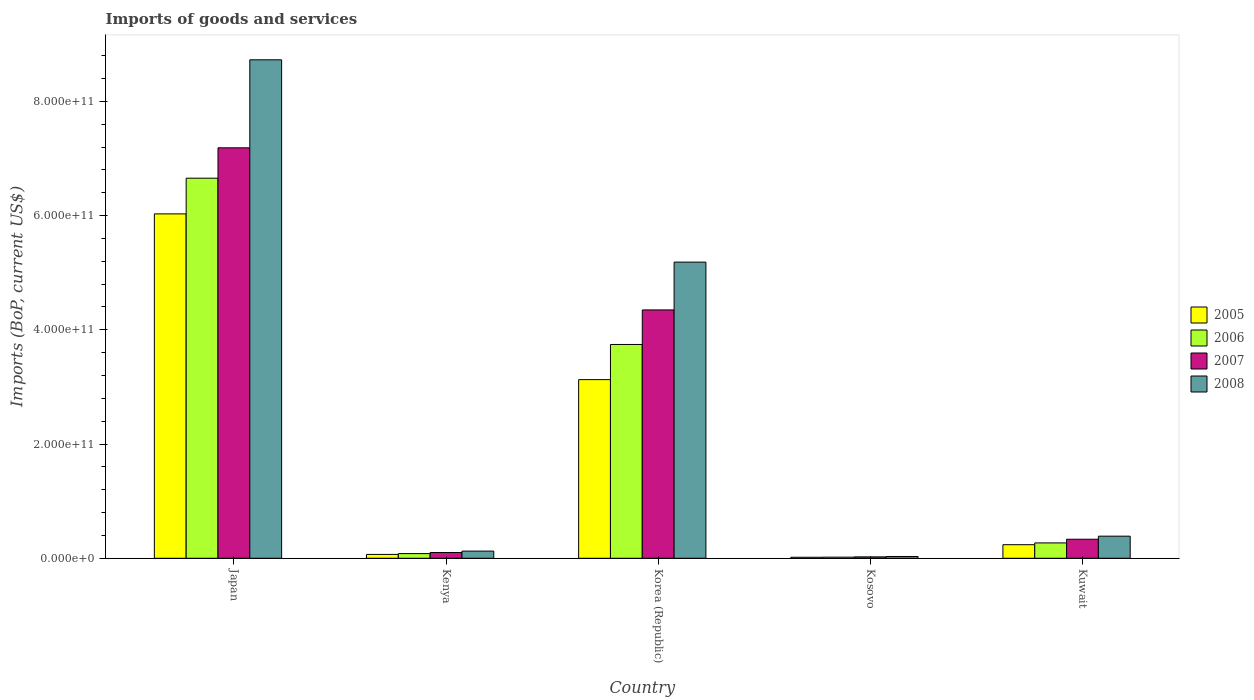Are the number of bars per tick equal to the number of legend labels?
Provide a short and direct response. Yes. Are the number of bars on each tick of the X-axis equal?
Make the answer very short. Yes. How many bars are there on the 5th tick from the right?
Ensure brevity in your answer.  4. What is the amount spent on imports in 2007 in Japan?
Offer a very short reply. 7.19e+11. Across all countries, what is the maximum amount spent on imports in 2006?
Offer a very short reply. 6.66e+11. Across all countries, what is the minimum amount spent on imports in 2008?
Your response must be concise. 3.12e+09. In which country was the amount spent on imports in 2008 maximum?
Provide a short and direct response. Japan. In which country was the amount spent on imports in 2005 minimum?
Provide a succinct answer. Kosovo. What is the total amount spent on imports in 2008 in the graph?
Provide a succinct answer. 1.45e+12. What is the difference between the amount spent on imports in 2006 in Korea (Republic) and that in Kuwait?
Your answer should be very brief. 3.47e+11. What is the difference between the amount spent on imports in 2005 in Korea (Republic) and the amount spent on imports in 2008 in Kenya?
Ensure brevity in your answer.  3.00e+11. What is the average amount spent on imports in 2006 per country?
Keep it short and to the point. 2.15e+11. What is the difference between the amount spent on imports of/in 2007 and amount spent on imports of/in 2005 in Korea (Republic)?
Ensure brevity in your answer.  1.22e+11. In how many countries, is the amount spent on imports in 2005 greater than 560000000000 US$?
Offer a terse response. 1. What is the ratio of the amount spent on imports in 2006 in Kenya to that in Kuwait?
Offer a very short reply. 0.3. Is the amount spent on imports in 2008 in Japan less than that in Kuwait?
Keep it short and to the point. No. Is the difference between the amount spent on imports in 2007 in Japan and Kosovo greater than the difference between the amount spent on imports in 2005 in Japan and Kosovo?
Provide a short and direct response. Yes. What is the difference between the highest and the second highest amount spent on imports in 2008?
Ensure brevity in your answer.  3.54e+11. What is the difference between the highest and the lowest amount spent on imports in 2008?
Ensure brevity in your answer.  8.70e+11. Is it the case that in every country, the sum of the amount spent on imports in 2006 and amount spent on imports in 2007 is greater than the sum of amount spent on imports in 2008 and amount spent on imports in 2005?
Offer a terse response. No. Is it the case that in every country, the sum of the amount spent on imports in 2005 and amount spent on imports in 2006 is greater than the amount spent on imports in 2007?
Ensure brevity in your answer.  Yes. How many bars are there?
Provide a succinct answer. 20. How many countries are there in the graph?
Offer a terse response. 5. What is the difference between two consecutive major ticks on the Y-axis?
Offer a terse response. 2.00e+11. Are the values on the major ticks of Y-axis written in scientific E-notation?
Provide a short and direct response. Yes. Does the graph contain grids?
Offer a very short reply. No. Where does the legend appear in the graph?
Give a very brief answer. Center right. How are the legend labels stacked?
Offer a very short reply. Vertical. What is the title of the graph?
Offer a very short reply. Imports of goods and services. What is the label or title of the Y-axis?
Your response must be concise. Imports (BoP, current US$). What is the Imports (BoP, current US$) of 2005 in Japan?
Your answer should be compact. 6.03e+11. What is the Imports (BoP, current US$) of 2006 in Japan?
Make the answer very short. 6.66e+11. What is the Imports (BoP, current US$) of 2007 in Japan?
Keep it short and to the point. 7.19e+11. What is the Imports (BoP, current US$) in 2008 in Japan?
Make the answer very short. 8.73e+11. What is the Imports (BoP, current US$) of 2005 in Kenya?
Make the answer very short. 6.74e+09. What is the Imports (BoP, current US$) of 2006 in Kenya?
Ensure brevity in your answer.  8.17e+09. What is the Imports (BoP, current US$) of 2007 in Kenya?
Your answer should be very brief. 1.01e+1. What is the Imports (BoP, current US$) in 2008 in Kenya?
Your answer should be compact. 1.26e+1. What is the Imports (BoP, current US$) of 2005 in Korea (Republic)?
Ensure brevity in your answer.  3.13e+11. What is the Imports (BoP, current US$) in 2006 in Korea (Republic)?
Offer a terse response. 3.74e+11. What is the Imports (BoP, current US$) of 2007 in Korea (Republic)?
Ensure brevity in your answer.  4.35e+11. What is the Imports (BoP, current US$) in 2008 in Korea (Republic)?
Your answer should be very brief. 5.19e+11. What is the Imports (BoP, current US$) in 2005 in Kosovo?
Provide a short and direct response. 1.76e+09. What is the Imports (BoP, current US$) of 2006 in Kosovo?
Your answer should be very brief. 1.95e+09. What is the Imports (BoP, current US$) of 2007 in Kosovo?
Ensure brevity in your answer.  2.46e+09. What is the Imports (BoP, current US$) in 2008 in Kosovo?
Make the answer very short. 3.12e+09. What is the Imports (BoP, current US$) in 2005 in Kuwait?
Your response must be concise. 2.38e+1. What is the Imports (BoP, current US$) in 2006 in Kuwait?
Your answer should be compact. 2.69e+1. What is the Imports (BoP, current US$) of 2007 in Kuwait?
Your answer should be very brief. 3.33e+1. What is the Imports (BoP, current US$) in 2008 in Kuwait?
Offer a terse response. 3.87e+1. Across all countries, what is the maximum Imports (BoP, current US$) in 2005?
Offer a terse response. 6.03e+11. Across all countries, what is the maximum Imports (BoP, current US$) of 2006?
Make the answer very short. 6.66e+11. Across all countries, what is the maximum Imports (BoP, current US$) of 2007?
Offer a very short reply. 7.19e+11. Across all countries, what is the maximum Imports (BoP, current US$) in 2008?
Offer a very short reply. 8.73e+11. Across all countries, what is the minimum Imports (BoP, current US$) of 2005?
Your answer should be very brief. 1.76e+09. Across all countries, what is the minimum Imports (BoP, current US$) of 2006?
Offer a very short reply. 1.95e+09. Across all countries, what is the minimum Imports (BoP, current US$) in 2007?
Provide a short and direct response. 2.46e+09. Across all countries, what is the minimum Imports (BoP, current US$) of 2008?
Offer a very short reply. 3.12e+09. What is the total Imports (BoP, current US$) of 2005 in the graph?
Your answer should be very brief. 9.48e+11. What is the total Imports (BoP, current US$) of 2006 in the graph?
Give a very brief answer. 1.08e+12. What is the total Imports (BoP, current US$) in 2007 in the graph?
Offer a very short reply. 1.20e+12. What is the total Imports (BoP, current US$) of 2008 in the graph?
Provide a short and direct response. 1.45e+12. What is the difference between the Imports (BoP, current US$) of 2005 in Japan and that in Kenya?
Ensure brevity in your answer.  5.96e+11. What is the difference between the Imports (BoP, current US$) of 2006 in Japan and that in Kenya?
Ensure brevity in your answer.  6.57e+11. What is the difference between the Imports (BoP, current US$) in 2007 in Japan and that in Kenya?
Keep it short and to the point. 7.09e+11. What is the difference between the Imports (BoP, current US$) of 2008 in Japan and that in Kenya?
Give a very brief answer. 8.60e+11. What is the difference between the Imports (BoP, current US$) in 2005 in Japan and that in Korea (Republic)?
Give a very brief answer. 2.90e+11. What is the difference between the Imports (BoP, current US$) in 2006 in Japan and that in Korea (Republic)?
Offer a very short reply. 2.91e+11. What is the difference between the Imports (BoP, current US$) of 2007 in Japan and that in Korea (Republic)?
Your answer should be compact. 2.84e+11. What is the difference between the Imports (BoP, current US$) of 2008 in Japan and that in Korea (Republic)?
Your answer should be compact. 3.54e+11. What is the difference between the Imports (BoP, current US$) of 2005 in Japan and that in Kosovo?
Make the answer very short. 6.01e+11. What is the difference between the Imports (BoP, current US$) of 2006 in Japan and that in Kosovo?
Make the answer very short. 6.64e+11. What is the difference between the Imports (BoP, current US$) in 2007 in Japan and that in Kosovo?
Your answer should be very brief. 7.16e+11. What is the difference between the Imports (BoP, current US$) in 2008 in Japan and that in Kosovo?
Give a very brief answer. 8.70e+11. What is the difference between the Imports (BoP, current US$) of 2005 in Japan and that in Kuwait?
Give a very brief answer. 5.79e+11. What is the difference between the Imports (BoP, current US$) in 2006 in Japan and that in Kuwait?
Your response must be concise. 6.39e+11. What is the difference between the Imports (BoP, current US$) in 2007 in Japan and that in Kuwait?
Make the answer very short. 6.85e+11. What is the difference between the Imports (BoP, current US$) of 2008 in Japan and that in Kuwait?
Your response must be concise. 8.34e+11. What is the difference between the Imports (BoP, current US$) of 2005 in Kenya and that in Korea (Republic)?
Offer a terse response. -3.06e+11. What is the difference between the Imports (BoP, current US$) in 2006 in Kenya and that in Korea (Republic)?
Offer a very short reply. -3.66e+11. What is the difference between the Imports (BoP, current US$) of 2007 in Kenya and that in Korea (Republic)?
Ensure brevity in your answer.  -4.25e+11. What is the difference between the Imports (BoP, current US$) of 2008 in Kenya and that in Korea (Republic)?
Offer a very short reply. -5.06e+11. What is the difference between the Imports (BoP, current US$) of 2005 in Kenya and that in Kosovo?
Your response must be concise. 4.97e+09. What is the difference between the Imports (BoP, current US$) in 2006 in Kenya and that in Kosovo?
Your answer should be compact. 6.22e+09. What is the difference between the Imports (BoP, current US$) in 2007 in Kenya and that in Kosovo?
Keep it short and to the point. 7.60e+09. What is the difference between the Imports (BoP, current US$) of 2008 in Kenya and that in Kosovo?
Your answer should be very brief. 9.44e+09. What is the difference between the Imports (BoP, current US$) of 2005 in Kenya and that in Kuwait?
Ensure brevity in your answer.  -1.70e+1. What is the difference between the Imports (BoP, current US$) in 2006 in Kenya and that in Kuwait?
Offer a terse response. -1.87e+1. What is the difference between the Imports (BoP, current US$) of 2007 in Kenya and that in Kuwait?
Your response must be concise. -2.32e+1. What is the difference between the Imports (BoP, current US$) of 2008 in Kenya and that in Kuwait?
Your answer should be very brief. -2.62e+1. What is the difference between the Imports (BoP, current US$) of 2005 in Korea (Republic) and that in Kosovo?
Provide a succinct answer. 3.11e+11. What is the difference between the Imports (BoP, current US$) in 2006 in Korea (Republic) and that in Kosovo?
Ensure brevity in your answer.  3.72e+11. What is the difference between the Imports (BoP, current US$) of 2007 in Korea (Republic) and that in Kosovo?
Give a very brief answer. 4.32e+11. What is the difference between the Imports (BoP, current US$) in 2008 in Korea (Republic) and that in Kosovo?
Provide a short and direct response. 5.15e+11. What is the difference between the Imports (BoP, current US$) in 2005 in Korea (Republic) and that in Kuwait?
Provide a succinct answer. 2.89e+11. What is the difference between the Imports (BoP, current US$) in 2006 in Korea (Republic) and that in Kuwait?
Make the answer very short. 3.47e+11. What is the difference between the Imports (BoP, current US$) in 2007 in Korea (Republic) and that in Kuwait?
Ensure brevity in your answer.  4.02e+11. What is the difference between the Imports (BoP, current US$) of 2008 in Korea (Republic) and that in Kuwait?
Provide a short and direct response. 4.80e+11. What is the difference between the Imports (BoP, current US$) of 2005 in Kosovo and that in Kuwait?
Your answer should be very brief. -2.20e+1. What is the difference between the Imports (BoP, current US$) in 2006 in Kosovo and that in Kuwait?
Your answer should be compact. -2.49e+1. What is the difference between the Imports (BoP, current US$) of 2007 in Kosovo and that in Kuwait?
Offer a very short reply. -3.08e+1. What is the difference between the Imports (BoP, current US$) of 2008 in Kosovo and that in Kuwait?
Provide a short and direct response. -3.56e+1. What is the difference between the Imports (BoP, current US$) of 2005 in Japan and the Imports (BoP, current US$) of 2006 in Kenya?
Provide a succinct answer. 5.95e+11. What is the difference between the Imports (BoP, current US$) in 2005 in Japan and the Imports (BoP, current US$) in 2007 in Kenya?
Offer a very short reply. 5.93e+11. What is the difference between the Imports (BoP, current US$) of 2005 in Japan and the Imports (BoP, current US$) of 2008 in Kenya?
Make the answer very short. 5.90e+11. What is the difference between the Imports (BoP, current US$) in 2006 in Japan and the Imports (BoP, current US$) in 2007 in Kenya?
Offer a terse response. 6.55e+11. What is the difference between the Imports (BoP, current US$) in 2006 in Japan and the Imports (BoP, current US$) in 2008 in Kenya?
Provide a succinct answer. 6.53e+11. What is the difference between the Imports (BoP, current US$) in 2007 in Japan and the Imports (BoP, current US$) in 2008 in Kenya?
Provide a succinct answer. 7.06e+11. What is the difference between the Imports (BoP, current US$) of 2005 in Japan and the Imports (BoP, current US$) of 2006 in Korea (Republic)?
Your answer should be compact. 2.29e+11. What is the difference between the Imports (BoP, current US$) of 2005 in Japan and the Imports (BoP, current US$) of 2007 in Korea (Republic)?
Your response must be concise. 1.68e+11. What is the difference between the Imports (BoP, current US$) of 2005 in Japan and the Imports (BoP, current US$) of 2008 in Korea (Republic)?
Your response must be concise. 8.45e+1. What is the difference between the Imports (BoP, current US$) in 2006 in Japan and the Imports (BoP, current US$) in 2007 in Korea (Republic)?
Make the answer very short. 2.31e+11. What is the difference between the Imports (BoP, current US$) in 2006 in Japan and the Imports (BoP, current US$) in 2008 in Korea (Republic)?
Make the answer very short. 1.47e+11. What is the difference between the Imports (BoP, current US$) in 2007 in Japan and the Imports (BoP, current US$) in 2008 in Korea (Republic)?
Your answer should be compact. 2.00e+11. What is the difference between the Imports (BoP, current US$) of 2005 in Japan and the Imports (BoP, current US$) of 2006 in Kosovo?
Your answer should be very brief. 6.01e+11. What is the difference between the Imports (BoP, current US$) of 2005 in Japan and the Imports (BoP, current US$) of 2007 in Kosovo?
Your response must be concise. 6.01e+11. What is the difference between the Imports (BoP, current US$) of 2005 in Japan and the Imports (BoP, current US$) of 2008 in Kosovo?
Ensure brevity in your answer.  6.00e+11. What is the difference between the Imports (BoP, current US$) of 2006 in Japan and the Imports (BoP, current US$) of 2007 in Kosovo?
Provide a succinct answer. 6.63e+11. What is the difference between the Imports (BoP, current US$) in 2006 in Japan and the Imports (BoP, current US$) in 2008 in Kosovo?
Give a very brief answer. 6.62e+11. What is the difference between the Imports (BoP, current US$) of 2007 in Japan and the Imports (BoP, current US$) of 2008 in Kosovo?
Offer a terse response. 7.16e+11. What is the difference between the Imports (BoP, current US$) in 2005 in Japan and the Imports (BoP, current US$) in 2006 in Kuwait?
Keep it short and to the point. 5.76e+11. What is the difference between the Imports (BoP, current US$) in 2005 in Japan and the Imports (BoP, current US$) in 2007 in Kuwait?
Ensure brevity in your answer.  5.70e+11. What is the difference between the Imports (BoP, current US$) of 2005 in Japan and the Imports (BoP, current US$) of 2008 in Kuwait?
Your answer should be very brief. 5.64e+11. What is the difference between the Imports (BoP, current US$) of 2006 in Japan and the Imports (BoP, current US$) of 2007 in Kuwait?
Make the answer very short. 6.32e+11. What is the difference between the Imports (BoP, current US$) in 2006 in Japan and the Imports (BoP, current US$) in 2008 in Kuwait?
Your answer should be compact. 6.27e+11. What is the difference between the Imports (BoP, current US$) of 2007 in Japan and the Imports (BoP, current US$) of 2008 in Kuwait?
Provide a succinct answer. 6.80e+11. What is the difference between the Imports (BoP, current US$) in 2005 in Kenya and the Imports (BoP, current US$) in 2006 in Korea (Republic)?
Provide a succinct answer. -3.68e+11. What is the difference between the Imports (BoP, current US$) of 2005 in Kenya and the Imports (BoP, current US$) of 2007 in Korea (Republic)?
Make the answer very short. -4.28e+11. What is the difference between the Imports (BoP, current US$) of 2005 in Kenya and the Imports (BoP, current US$) of 2008 in Korea (Republic)?
Give a very brief answer. -5.12e+11. What is the difference between the Imports (BoP, current US$) of 2006 in Kenya and the Imports (BoP, current US$) of 2007 in Korea (Republic)?
Offer a very short reply. -4.27e+11. What is the difference between the Imports (BoP, current US$) of 2006 in Kenya and the Imports (BoP, current US$) of 2008 in Korea (Republic)?
Your response must be concise. -5.10e+11. What is the difference between the Imports (BoP, current US$) in 2007 in Kenya and the Imports (BoP, current US$) in 2008 in Korea (Republic)?
Your response must be concise. -5.09e+11. What is the difference between the Imports (BoP, current US$) of 2005 in Kenya and the Imports (BoP, current US$) of 2006 in Kosovo?
Offer a terse response. 4.79e+09. What is the difference between the Imports (BoP, current US$) in 2005 in Kenya and the Imports (BoP, current US$) in 2007 in Kosovo?
Your answer should be very brief. 4.28e+09. What is the difference between the Imports (BoP, current US$) in 2005 in Kenya and the Imports (BoP, current US$) in 2008 in Kosovo?
Provide a short and direct response. 3.62e+09. What is the difference between the Imports (BoP, current US$) of 2006 in Kenya and the Imports (BoP, current US$) of 2007 in Kosovo?
Ensure brevity in your answer.  5.71e+09. What is the difference between the Imports (BoP, current US$) of 2006 in Kenya and the Imports (BoP, current US$) of 2008 in Kosovo?
Keep it short and to the point. 5.05e+09. What is the difference between the Imports (BoP, current US$) of 2007 in Kenya and the Imports (BoP, current US$) of 2008 in Kosovo?
Your response must be concise. 6.94e+09. What is the difference between the Imports (BoP, current US$) in 2005 in Kenya and the Imports (BoP, current US$) in 2006 in Kuwait?
Offer a very short reply. -2.01e+1. What is the difference between the Imports (BoP, current US$) in 2005 in Kenya and the Imports (BoP, current US$) in 2007 in Kuwait?
Keep it short and to the point. -2.66e+1. What is the difference between the Imports (BoP, current US$) in 2005 in Kenya and the Imports (BoP, current US$) in 2008 in Kuwait?
Your answer should be compact. -3.20e+1. What is the difference between the Imports (BoP, current US$) of 2006 in Kenya and the Imports (BoP, current US$) of 2007 in Kuwait?
Offer a very short reply. -2.51e+1. What is the difference between the Imports (BoP, current US$) in 2006 in Kenya and the Imports (BoP, current US$) in 2008 in Kuwait?
Provide a short and direct response. -3.05e+1. What is the difference between the Imports (BoP, current US$) of 2007 in Kenya and the Imports (BoP, current US$) of 2008 in Kuwait?
Offer a very short reply. -2.87e+1. What is the difference between the Imports (BoP, current US$) in 2005 in Korea (Republic) and the Imports (BoP, current US$) in 2006 in Kosovo?
Make the answer very short. 3.11e+11. What is the difference between the Imports (BoP, current US$) of 2005 in Korea (Republic) and the Imports (BoP, current US$) of 2007 in Kosovo?
Your response must be concise. 3.10e+11. What is the difference between the Imports (BoP, current US$) in 2005 in Korea (Republic) and the Imports (BoP, current US$) in 2008 in Kosovo?
Provide a short and direct response. 3.10e+11. What is the difference between the Imports (BoP, current US$) in 2006 in Korea (Republic) and the Imports (BoP, current US$) in 2007 in Kosovo?
Provide a succinct answer. 3.72e+11. What is the difference between the Imports (BoP, current US$) in 2006 in Korea (Republic) and the Imports (BoP, current US$) in 2008 in Kosovo?
Offer a very short reply. 3.71e+11. What is the difference between the Imports (BoP, current US$) of 2007 in Korea (Republic) and the Imports (BoP, current US$) of 2008 in Kosovo?
Provide a succinct answer. 4.32e+11. What is the difference between the Imports (BoP, current US$) of 2005 in Korea (Republic) and the Imports (BoP, current US$) of 2006 in Kuwait?
Ensure brevity in your answer.  2.86e+11. What is the difference between the Imports (BoP, current US$) of 2005 in Korea (Republic) and the Imports (BoP, current US$) of 2007 in Kuwait?
Give a very brief answer. 2.79e+11. What is the difference between the Imports (BoP, current US$) in 2005 in Korea (Republic) and the Imports (BoP, current US$) in 2008 in Kuwait?
Your answer should be very brief. 2.74e+11. What is the difference between the Imports (BoP, current US$) of 2006 in Korea (Republic) and the Imports (BoP, current US$) of 2007 in Kuwait?
Provide a short and direct response. 3.41e+11. What is the difference between the Imports (BoP, current US$) of 2006 in Korea (Republic) and the Imports (BoP, current US$) of 2008 in Kuwait?
Offer a terse response. 3.36e+11. What is the difference between the Imports (BoP, current US$) of 2007 in Korea (Republic) and the Imports (BoP, current US$) of 2008 in Kuwait?
Provide a succinct answer. 3.96e+11. What is the difference between the Imports (BoP, current US$) in 2005 in Kosovo and the Imports (BoP, current US$) in 2006 in Kuwait?
Give a very brief answer. -2.51e+1. What is the difference between the Imports (BoP, current US$) of 2005 in Kosovo and the Imports (BoP, current US$) of 2007 in Kuwait?
Keep it short and to the point. -3.15e+1. What is the difference between the Imports (BoP, current US$) in 2005 in Kosovo and the Imports (BoP, current US$) in 2008 in Kuwait?
Keep it short and to the point. -3.70e+1. What is the difference between the Imports (BoP, current US$) of 2006 in Kosovo and the Imports (BoP, current US$) of 2007 in Kuwait?
Offer a very short reply. -3.14e+1. What is the difference between the Imports (BoP, current US$) in 2006 in Kosovo and the Imports (BoP, current US$) in 2008 in Kuwait?
Offer a very short reply. -3.68e+1. What is the difference between the Imports (BoP, current US$) of 2007 in Kosovo and the Imports (BoP, current US$) of 2008 in Kuwait?
Offer a terse response. -3.63e+1. What is the average Imports (BoP, current US$) in 2005 per country?
Provide a short and direct response. 1.90e+11. What is the average Imports (BoP, current US$) of 2006 per country?
Provide a short and direct response. 2.15e+11. What is the average Imports (BoP, current US$) in 2007 per country?
Provide a succinct answer. 2.40e+11. What is the average Imports (BoP, current US$) in 2008 per country?
Ensure brevity in your answer.  2.89e+11. What is the difference between the Imports (BoP, current US$) in 2005 and Imports (BoP, current US$) in 2006 in Japan?
Provide a short and direct response. -6.25e+1. What is the difference between the Imports (BoP, current US$) in 2005 and Imports (BoP, current US$) in 2007 in Japan?
Your answer should be very brief. -1.16e+11. What is the difference between the Imports (BoP, current US$) of 2005 and Imports (BoP, current US$) of 2008 in Japan?
Offer a very short reply. -2.70e+11. What is the difference between the Imports (BoP, current US$) of 2006 and Imports (BoP, current US$) of 2007 in Japan?
Your answer should be compact. -5.32e+1. What is the difference between the Imports (BoP, current US$) in 2006 and Imports (BoP, current US$) in 2008 in Japan?
Offer a terse response. -2.07e+11. What is the difference between the Imports (BoP, current US$) in 2007 and Imports (BoP, current US$) in 2008 in Japan?
Your answer should be very brief. -1.54e+11. What is the difference between the Imports (BoP, current US$) of 2005 and Imports (BoP, current US$) of 2006 in Kenya?
Keep it short and to the point. -1.43e+09. What is the difference between the Imports (BoP, current US$) of 2005 and Imports (BoP, current US$) of 2007 in Kenya?
Provide a succinct answer. -3.32e+09. What is the difference between the Imports (BoP, current US$) in 2005 and Imports (BoP, current US$) in 2008 in Kenya?
Your answer should be very brief. -5.82e+09. What is the difference between the Imports (BoP, current US$) in 2006 and Imports (BoP, current US$) in 2007 in Kenya?
Your answer should be compact. -1.89e+09. What is the difference between the Imports (BoP, current US$) of 2006 and Imports (BoP, current US$) of 2008 in Kenya?
Offer a very short reply. -4.39e+09. What is the difference between the Imports (BoP, current US$) in 2007 and Imports (BoP, current US$) in 2008 in Kenya?
Provide a succinct answer. -2.50e+09. What is the difference between the Imports (BoP, current US$) in 2005 and Imports (BoP, current US$) in 2006 in Korea (Republic)?
Offer a terse response. -6.16e+1. What is the difference between the Imports (BoP, current US$) in 2005 and Imports (BoP, current US$) in 2007 in Korea (Republic)?
Give a very brief answer. -1.22e+11. What is the difference between the Imports (BoP, current US$) of 2005 and Imports (BoP, current US$) of 2008 in Korea (Republic)?
Make the answer very short. -2.06e+11. What is the difference between the Imports (BoP, current US$) in 2006 and Imports (BoP, current US$) in 2007 in Korea (Republic)?
Make the answer very short. -6.05e+1. What is the difference between the Imports (BoP, current US$) in 2006 and Imports (BoP, current US$) in 2008 in Korea (Republic)?
Your answer should be very brief. -1.44e+11. What is the difference between the Imports (BoP, current US$) of 2007 and Imports (BoP, current US$) of 2008 in Korea (Republic)?
Your answer should be very brief. -8.37e+1. What is the difference between the Imports (BoP, current US$) of 2005 and Imports (BoP, current US$) of 2006 in Kosovo?
Your answer should be very brief. -1.86e+08. What is the difference between the Imports (BoP, current US$) of 2005 and Imports (BoP, current US$) of 2007 in Kosovo?
Provide a succinct answer. -6.96e+08. What is the difference between the Imports (BoP, current US$) of 2005 and Imports (BoP, current US$) of 2008 in Kosovo?
Ensure brevity in your answer.  -1.36e+09. What is the difference between the Imports (BoP, current US$) of 2006 and Imports (BoP, current US$) of 2007 in Kosovo?
Keep it short and to the point. -5.10e+08. What is the difference between the Imports (BoP, current US$) of 2006 and Imports (BoP, current US$) of 2008 in Kosovo?
Give a very brief answer. -1.17e+09. What is the difference between the Imports (BoP, current US$) in 2007 and Imports (BoP, current US$) in 2008 in Kosovo?
Your answer should be very brief. -6.61e+08. What is the difference between the Imports (BoP, current US$) of 2005 and Imports (BoP, current US$) of 2006 in Kuwait?
Offer a very short reply. -3.11e+09. What is the difference between the Imports (BoP, current US$) of 2005 and Imports (BoP, current US$) of 2007 in Kuwait?
Your response must be concise. -9.54e+09. What is the difference between the Imports (BoP, current US$) in 2005 and Imports (BoP, current US$) in 2008 in Kuwait?
Keep it short and to the point. -1.49e+1. What is the difference between the Imports (BoP, current US$) in 2006 and Imports (BoP, current US$) in 2007 in Kuwait?
Offer a terse response. -6.43e+09. What is the difference between the Imports (BoP, current US$) of 2006 and Imports (BoP, current US$) of 2008 in Kuwait?
Your response must be concise. -1.18e+1. What is the difference between the Imports (BoP, current US$) of 2007 and Imports (BoP, current US$) of 2008 in Kuwait?
Keep it short and to the point. -5.41e+09. What is the ratio of the Imports (BoP, current US$) of 2005 in Japan to that in Kenya?
Provide a short and direct response. 89.49. What is the ratio of the Imports (BoP, current US$) in 2006 in Japan to that in Kenya?
Provide a succinct answer. 81.45. What is the ratio of the Imports (BoP, current US$) in 2007 in Japan to that in Kenya?
Make the answer very short. 71.45. What is the ratio of the Imports (BoP, current US$) in 2008 in Japan to that in Kenya?
Offer a very short reply. 69.5. What is the ratio of the Imports (BoP, current US$) in 2005 in Japan to that in Korea (Republic)?
Your answer should be compact. 1.93. What is the ratio of the Imports (BoP, current US$) in 2006 in Japan to that in Korea (Republic)?
Keep it short and to the point. 1.78. What is the ratio of the Imports (BoP, current US$) of 2007 in Japan to that in Korea (Republic)?
Your answer should be compact. 1.65. What is the ratio of the Imports (BoP, current US$) in 2008 in Japan to that in Korea (Republic)?
Keep it short and to the point. 1.68. What is the ratio of the Imports (BoP, current US$) in 2005 in Japan to that in Kosovo?
Provide a succinct answer. 341.77. What is the ratio of the Imports (BoP, current US$) in 2006 in Japan to that in Kosovo?
Your answer should be very brief. 341.28. What is the ratio of the Imports (BoP, current US$) of 2007 in Japan to that in Kosovo?
Keep it short and to the point. 292.13. What is the ratio of the Imports (BoP, current US$) in 2008 in Japan to that in Kosovo?
Your response must be concise. 279.68. What is the ratio of the Imports (BoP, current US$) of 2005 in Japan to that in Kuwait?
Keep it short and to the point. 25.37. What is the ratio of the Imports (BoP, current US$) in 2006 in Japan to that in Kuwait?
Make the answer very short. 24.76. What is the ratio of the Imports (BoP, current US$) of 2007 in Japan to that in Kuwait?
Ensure brevity in your answer.  21.58. What is the ratio of the Imports (BoP, current US$) of 2008 in Japan to that in Kuwait?
Your answer should be compact. 22.54. What is the ratio of the Imports (BoP, current US$) in 2005 in Kenya to that in Korea (Republic)?
Ensure brevity in your answer.  0.02. What is the ratio of the Imports (BoP, current US$) in 2006 in Kenya to that in Korea (Republic)?
Your answer should be compact. 0.02. What is the ratio of the Imports (BoP, current US$) in 2007 in Kenya to that in Korea (Republic)?
Your response must be concise. 0.02. What is the ratio of the Imports (BoP, current US$) of 2008 in Kenya to that in Korea (Republic)?
Your answer should be compact. 0.02. What is the ratio of the Imports (BoP, current US$) of 2005 in Kenya to that in Kosovo?
Your answer should be very brief. 3.82. What is the ratio of the Imports (BoP, current US$) in 2006 in Kenya to that in Kosovo?
Provide a short and direct response. 4.19. What is the ratio of the Imports (BoP, current US$) in 2007 in Kenya to that in Kosovo?
Keep it short and to the point. 4.09. What is the ratio of the Imports (BoP, current US$) of 2008 in Kenya to that in Kosovo?
Keep it short and to the point. 4.02. What is the ratio of the Imports (BoP, current US$) in 2005 in Kenya to that in Kuwait?
Provide a succinct answer. 0.28. What is the ratio of the Imports (BoP, current US$) of 2006 in Kenya to that in Kuwait?
Provide a short and direct response. 0.3. What is the ratio of the Imports (BoP, current US$) in 2007 in Kenya to that in Kuwait?
Make the answer very short. 0.3. What is the ratio of the Imports (BoP, current US$) in 2008 in Kenya to that in Kuwait?
Provide a short and direct response. 0.32. What is the ratio of the Imports (BoP, current US$) of 2005 in Korea (Republic) to that in Kosovo?
Provide a succinct answer. 177.28. What is the ratio of the Imports (BoP, current US$) of 2006 in Korea (Republic) to that in Kosovo?
Keep it short and to the point. 191.97. What is the ratio of the Imports (BoP, current US$) of 2007 in Korea (Republic) to that in Kosovo?
Offer a very short reply. 176.75. What is the ratio of the Imports (BoP, current US$) in 2008 in Korea (Republic) to that in Kosovo?
Your answer should be compact. 166.17. What is the ratio of the Imports (BoP, current US$) in 2005 in Korea (Republic) to that in Kuwait?
Your response must be concise. 13.16. What is the ratio of the Imports (BoP, current US$) of 2006 in Korea (Republic) to that in Kuwait?
Your answer should be very brief. 13.93. What is the ratio of the Imports (BoP, current US$) of 2007 in Korea (Republic) to that in Kuwait?
Give a very brief answer. 13.06. What is the ratio of the Imports (BoP, current US$) in 2008 in Korea (Republic) to that in Kuwait?
Provide a succinct answer. 13.39. What is the ratio of the Imports (BoP, current US$) in 2005 in Kosovo to that in Kuwait?
Your answer should be compact. 0.07. What is the ratio of the Imports (BoP, current US$) of 2006 in Kosovo to that in Kuwait?
Ensure brevity in your answer.  0.07. What is the ratio of the Imports (BoP, current US$) in 2007 in Kosovo to that in Kuwait?
Your answer should be compact. 0.07. What is the ratio of the Imports (BoP, current US$) in 2008 in Kosovo to that in Kuwait?
Provide a short and direct response. 0.08. What is the difference between the highest and the second highest Imports (BoP, current US$) in 2005?
Ensure brevity in your answer.  2.90e+11. What is the difference between the highest and the second highest Imports (BoP, current US$) of 2006?
Provide a short and direct response. 2.91e+11. What is the difference between the highest and the second highest Imports (BoP, current US$) of 2007?
Ensure brevity in your answer.  2.84e+11. What is the difference between the highest and the second highest Imports (BoP, current US$) in 2008?
Make the answer very short. 3.54e+11. What is the difference between the highest and the lowest Imports (BoP, current US$) in 2005?
Provide a succinct answer. 6.01e+11. What is the difference between the highest and the lowest Imports (BoP, current US$) in 2006?
Your answer should be compact. 6.64e+11. What is the difference between the highest and the lowest Imports (BoP, current US$) in 2007?
Give a very brief answer. 7.16e+11. What is the difference between the highest and the lowest Imports (BoP, current US$) in 2008?
Keep it short and to the point. 8.70e+11. 